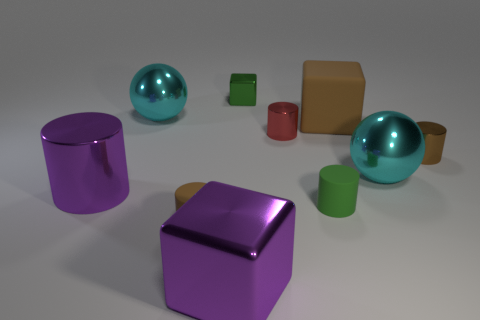The green cylinder has what size?
Your response must be concise. Small. Are there any large blue things that have the same shape as the green rubber thing?
Keep it short and to the point. No. What number of things are either small gray metallic objects or purple things behind the small brown rubber cylinder?
Give a very brief answer. 1. What color is the big metal ball that is right of the tiny red cylinder?
Your answer should be compact. Cyan. Do the cyan sphere on the right side of the big rubber object and the green matte object that is on the left side of the big brown rubber thing have the same size?
Make the answer very short. No. Are there any gray shiny balls of the same size as the brown metal cylinder?
Provide a succinct answer. No. What number of small matte things are left of the large cyan metal sphere behind the red metallic cylinder?
Keep it short and to the point. 0. What is the large purple cube made of?
Your answer should be very brief. Metal. How many green cylinders are in front of the tiny red thing?
Your answer should be very brief. 1. Do the big metal block and the large cylinder have the same color?
Give a very brief answer. Yes. 